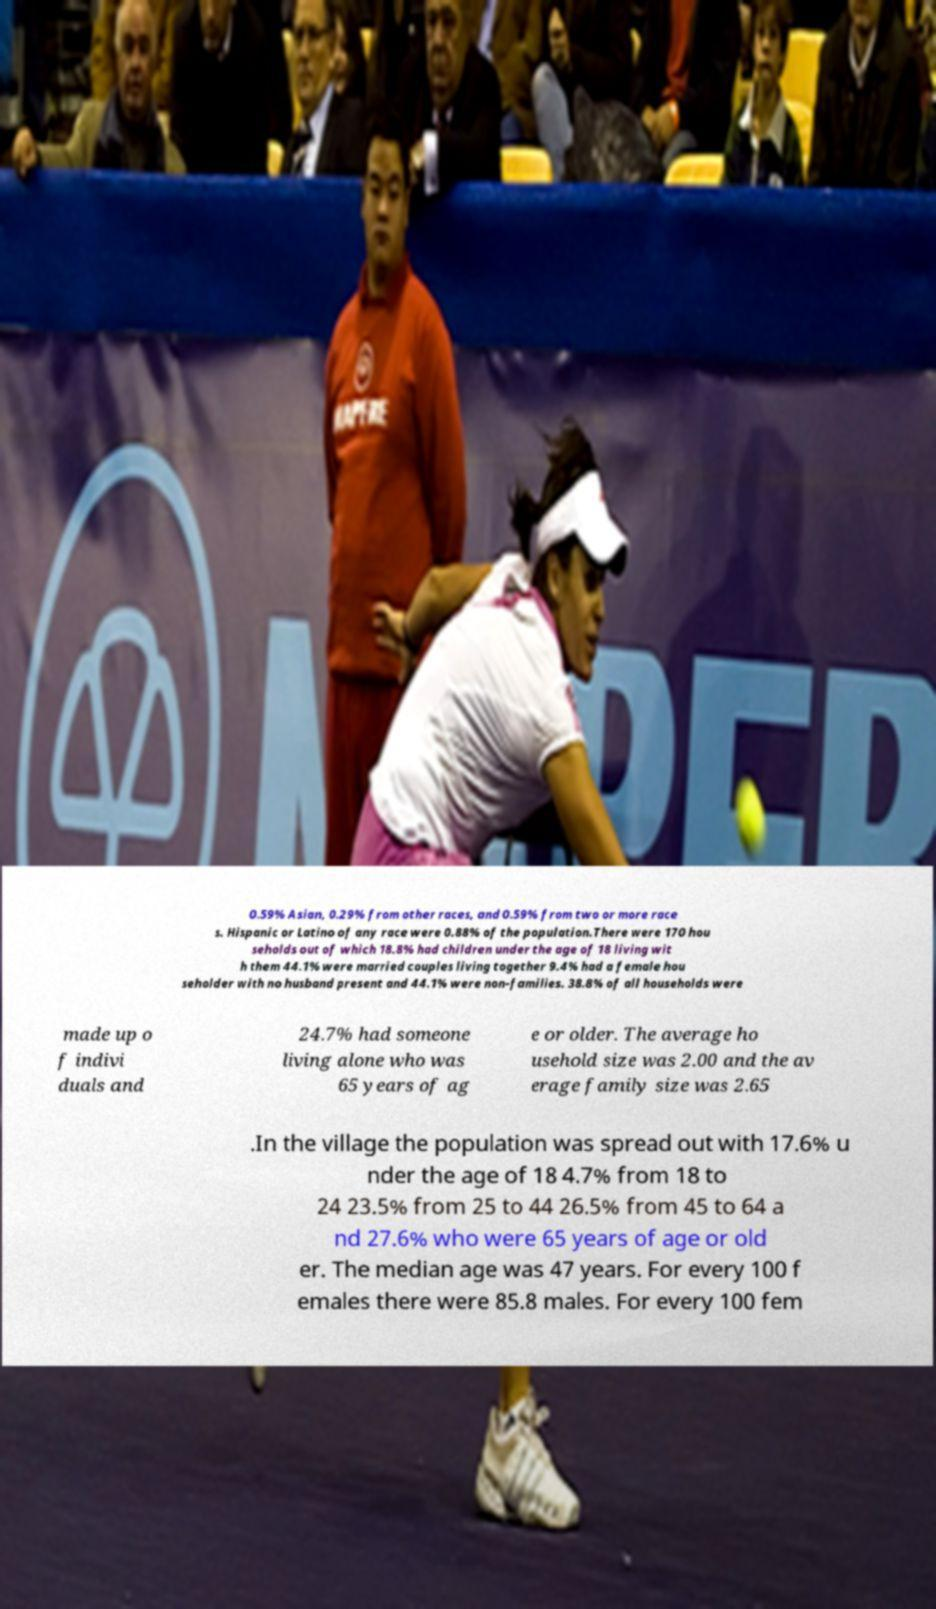Can you accurately transcribe the text from the provided image for me? 0.59% Asian, 0.29% from other races, and 0.59% from two or more race s. Hispanic or Latino of any race were 0.88% of the population.There were 170 hou seholds out of which 18.8% had children under the age of 18 living wit h them 44.1% were married couples living together 9.4% had a female hou seholder with no husband present and 44.1% were non-families. 38.8% of all households were made up o f indivi duals and 24.7% had someone living alone who was 65 years of ag e or older. The average ho usehold size was 2.00 and the av erage family size was 2.65 .In the village the population was spread out with 17.6% u nder the age of 18 4.7% from 18 to 24 23.5% from 25 to 44 26.5% from 45 to 64 a nd 27.6% who were 65 years of age or old er. The median age was 47 years. For every 100 f emales there were 85.8 males. For every 100 fem 